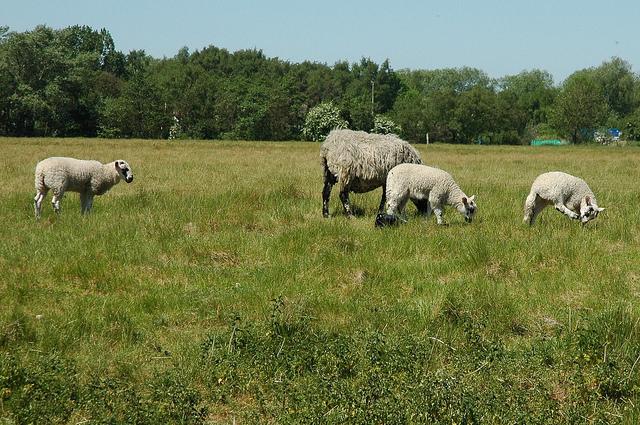Why are the sheep all headed right?
Short answer required. Grazing. What kind of animal is depicted in this image?
Keep it brief. Sheep. What are the white animals?
Write a very short answer. Sheep. Which sheep appears to have longer legs?
Quick response, please. Second from left. How many animals are in the picture?
Keep it brief. 4. Is this a grassy field?
Be succinct. Yes. 